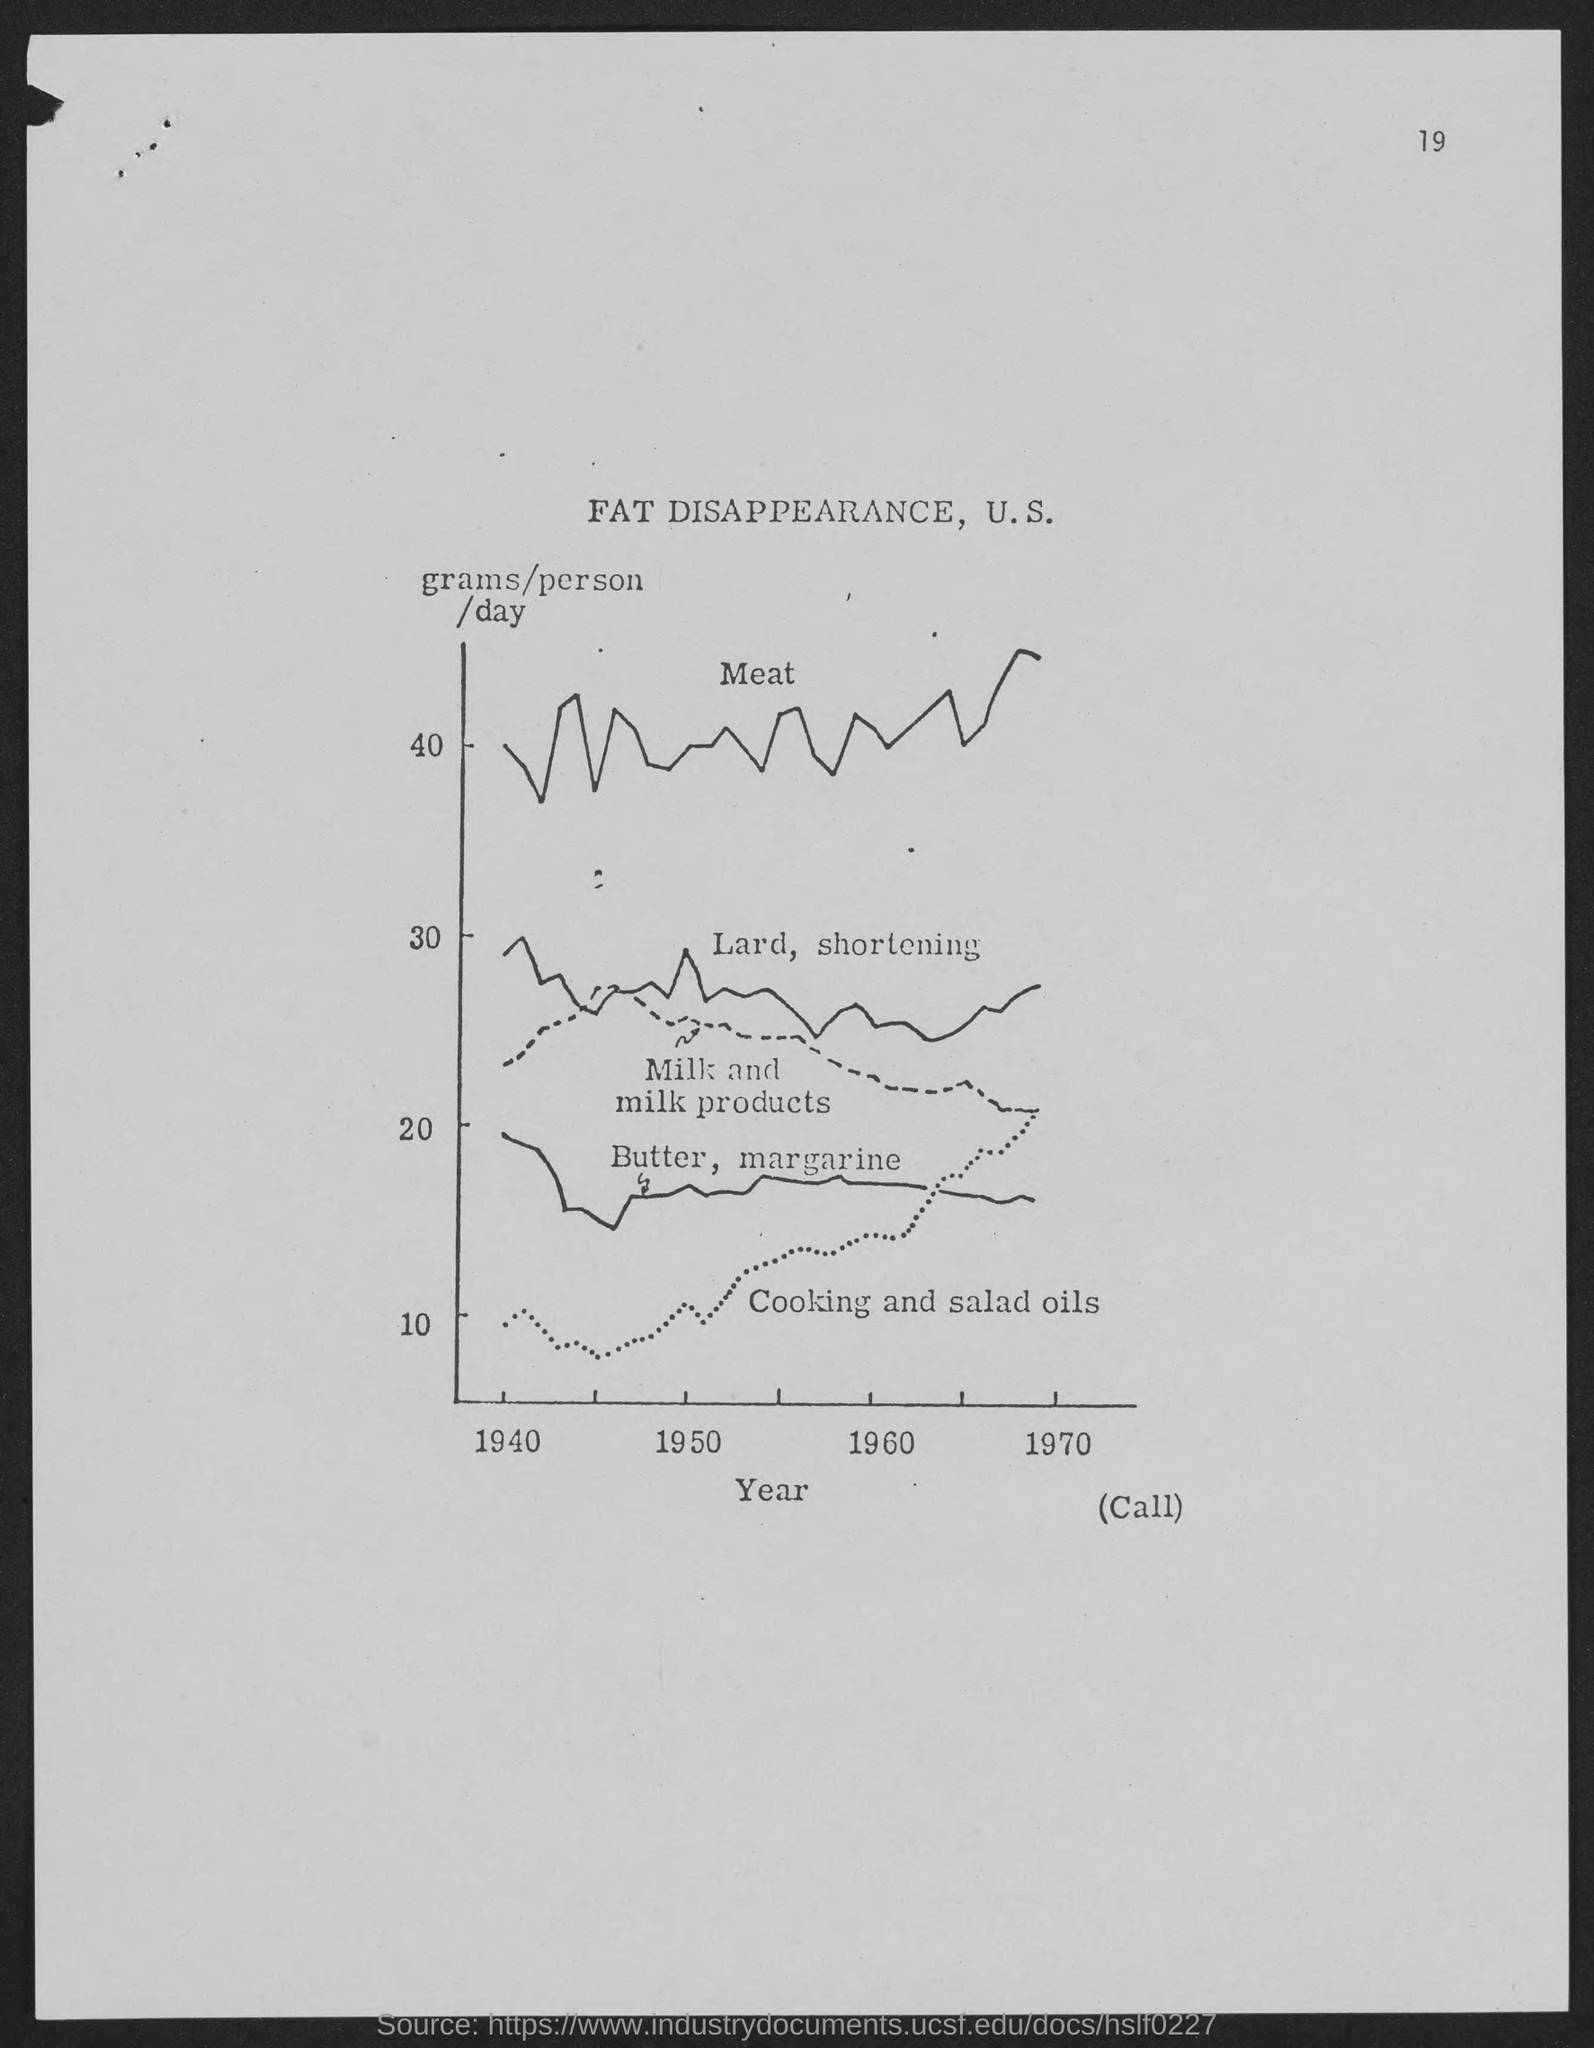What is the number at top-right corner of the page?
Offer a terse response. 19. 